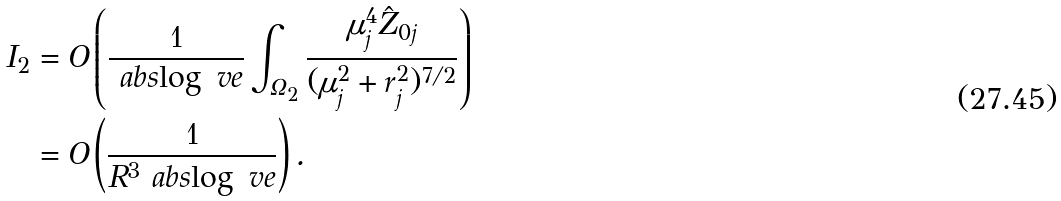Convert formula to latex. <formula><loc_0><loc_0><loc_500><loc_500>I _ { 2 } & = O \left ( \frac { 1 } { \ a b s { \log \ v e } } \int _ { \Omega _ { 2 } } \frac { \mu _ { j } ^ { 4 } \hat { Z } _ { 0 j } } { ( \mu _ { j } ^ { 2 } + r _ { j } ^ { 2 } ) ^ { 7 / 2 } } \right ) \\ & = O \left ( \frac { 1 } { R ^ { 3 } \ a b s { \log \ v e } } \right ) .</formula> 